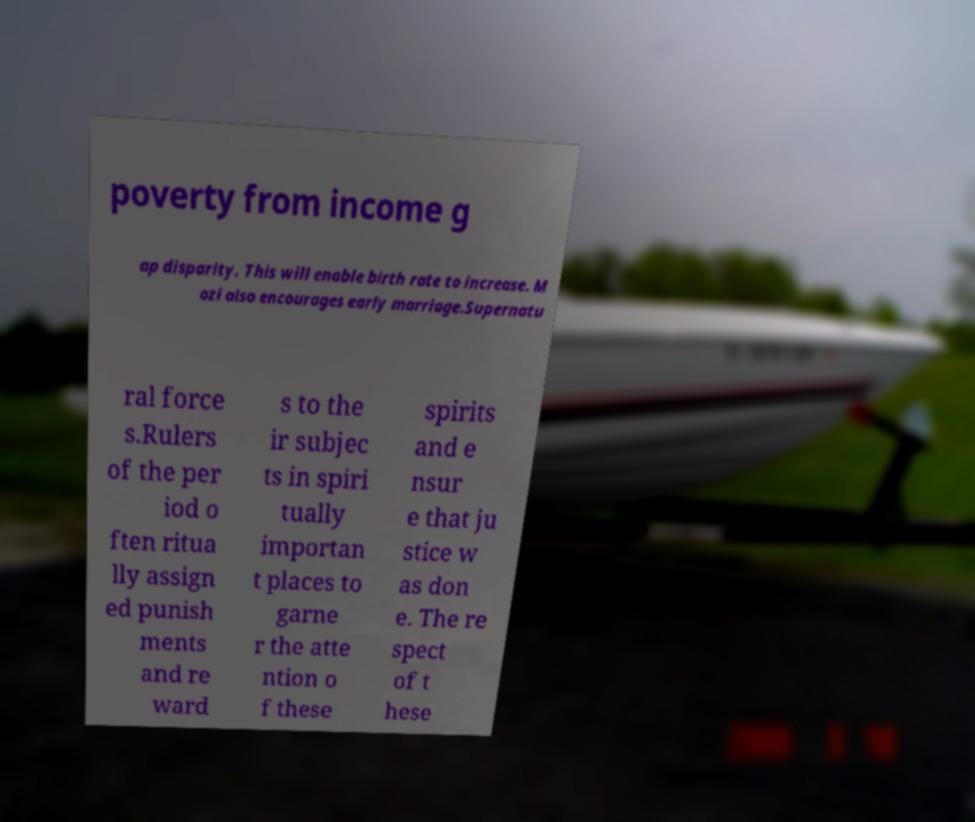Can you read and provide the text displayed in the image?This photo seems to have some interesting text. Can you extract and type it out for me? poverty from income g ap disparity. This will enable birth rate to increase. M ozi also encourages early marriage.Supernatu ral force s.Rulers of the per iod o ften ritua lly assign ed punish ments and re ward s to the ir subjec ts in spiri tually importan t places to garne r the atte ntion o f these spirits and e nsur e that ju stice w as don e. The re spect of t hese 